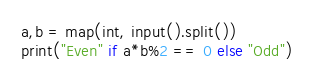Convert code to text. <code><loc_0><loc_0><loc_500><loc_500><_Python_>a,b = map(int, input().split())
print("Even" if a*b%2 == 0 else "Odd")</code> 